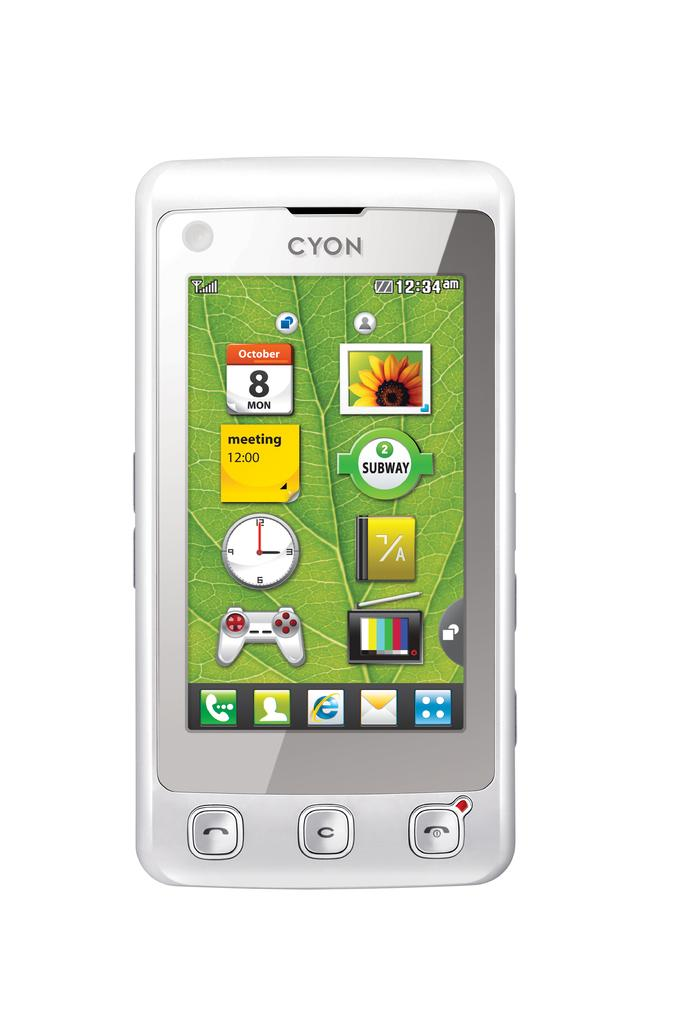Provide a one-sentence caption for the provided image. A white cell phone says Cyon on the top and shows the home screen. 